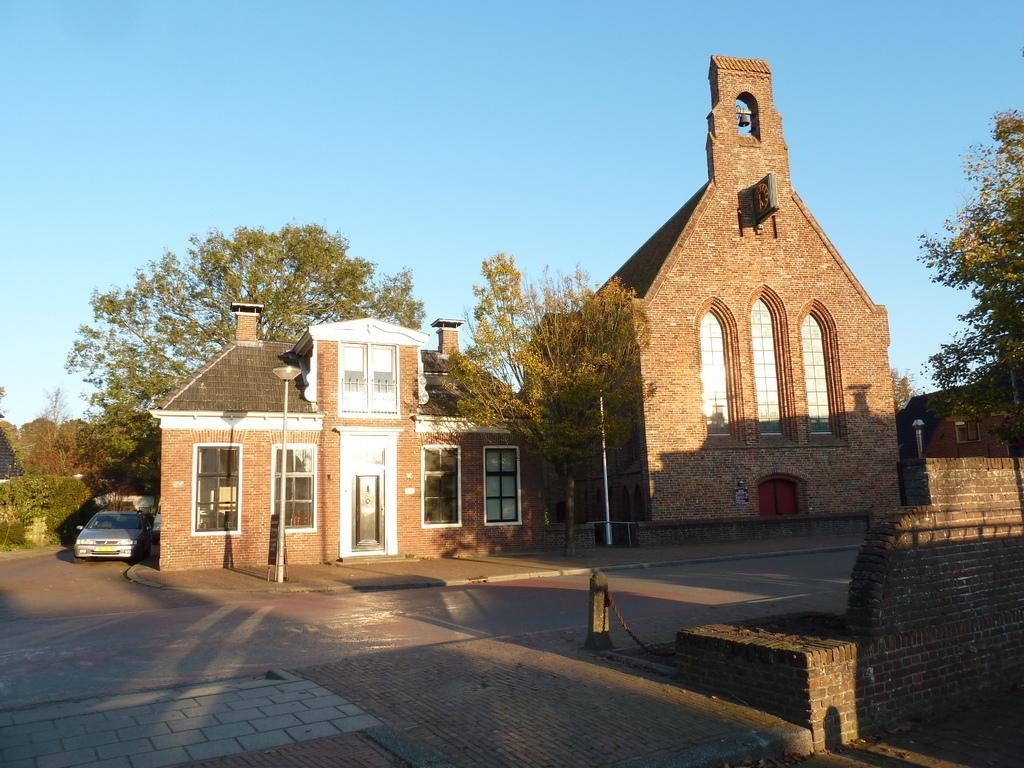In one or two sentences, can you explain what this image depicts? In this picture there is a building, beside that there is a church. In the background we can see many trees. On the left there is a car near to the plants. On the right we can see the brick wall near to the road. At the top there is a sky. 